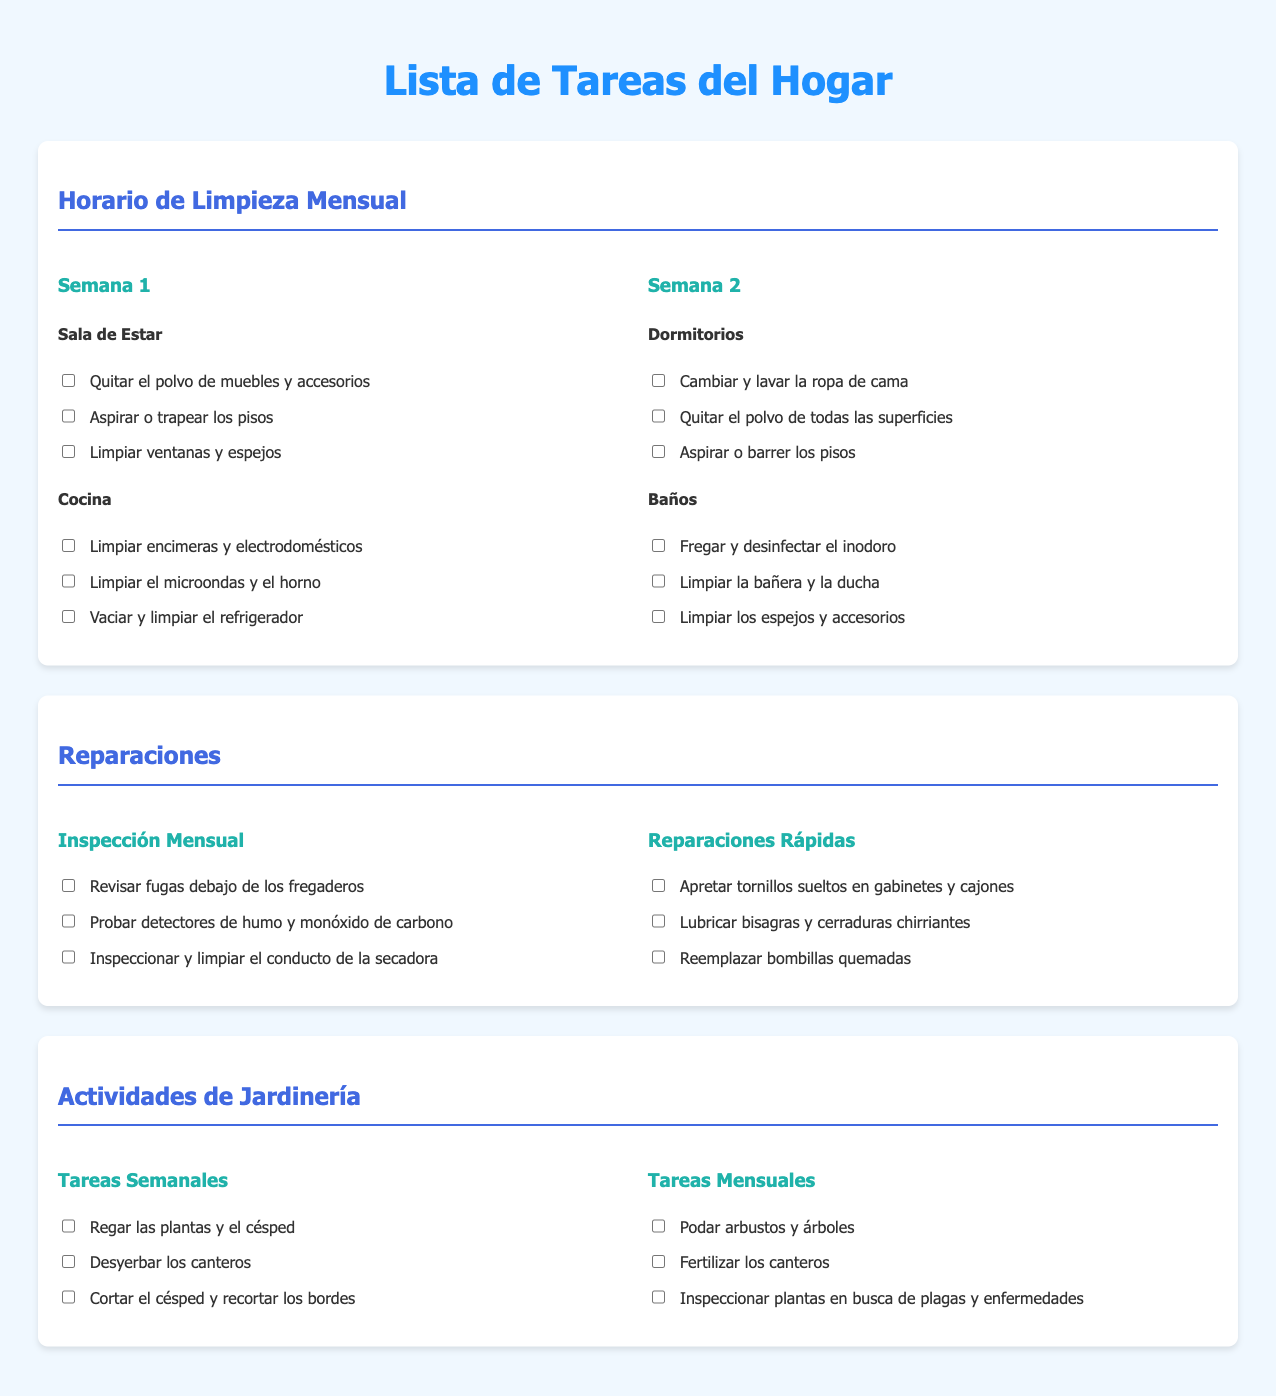¿Qué tareas se deben realizar en la sala de estar durante la primera semana? En la sala de estar, se debe quitar el polvo de muebles y accesorios, aspirar o trapear los pisos, y limpiar ventanas y espejos.
Answer: Quitar el polvo, aspirar, limpiar ventanas ¿Cuántas tareas de jardinería se mencionan para las actividades semanales? En las actividades de jardinería, se mencionan tres tareas para las actividades semanales.
Answer: Tres ¿Cuál es una de las tareas que se debe hacer en la cocina? Una de las tareas en la cocina es limpiar encimeras y electrodomésticos.
Answer: Limpiar encimeras ¿Qué se debe revisar durante la inspección mensual? Durante la inspección mensual, se deben revisar las fugas debajo de los fregaderos, probar detectores de humo y monóxido de carbono, e inspeccionar el conducto de la secadora.
Answer: Revisar fugas ¿Cuántas tareas hay en total para las reparaciones rápidas? Para las reparaciones rápidas, hay tres tareas listadas.
Answer: Tres ¿Qué actividad corresponde a la segunda semana en los dormitorios? En los dormitorios, la actividad correspondiente a la segunda semana es cambiar y lavar la ropa de cama.
Answer: Cambiar y lavar ropa de cama ¿Cuáles son las tareas mensuales de jardinería? Las tareas mensuales de jardinería incluyen podar arbustos y árboles, fertilizar los canteros, e inspeccionar plantas en busca de plagas y enfermedades.
Answer: Podar, fertilizar, inspeccionar ¿Qué color se utiliza para el título principal de la lista de tareas? El color utilizado para el título principal de la lista de tareas es azul.
Answer: Azul 